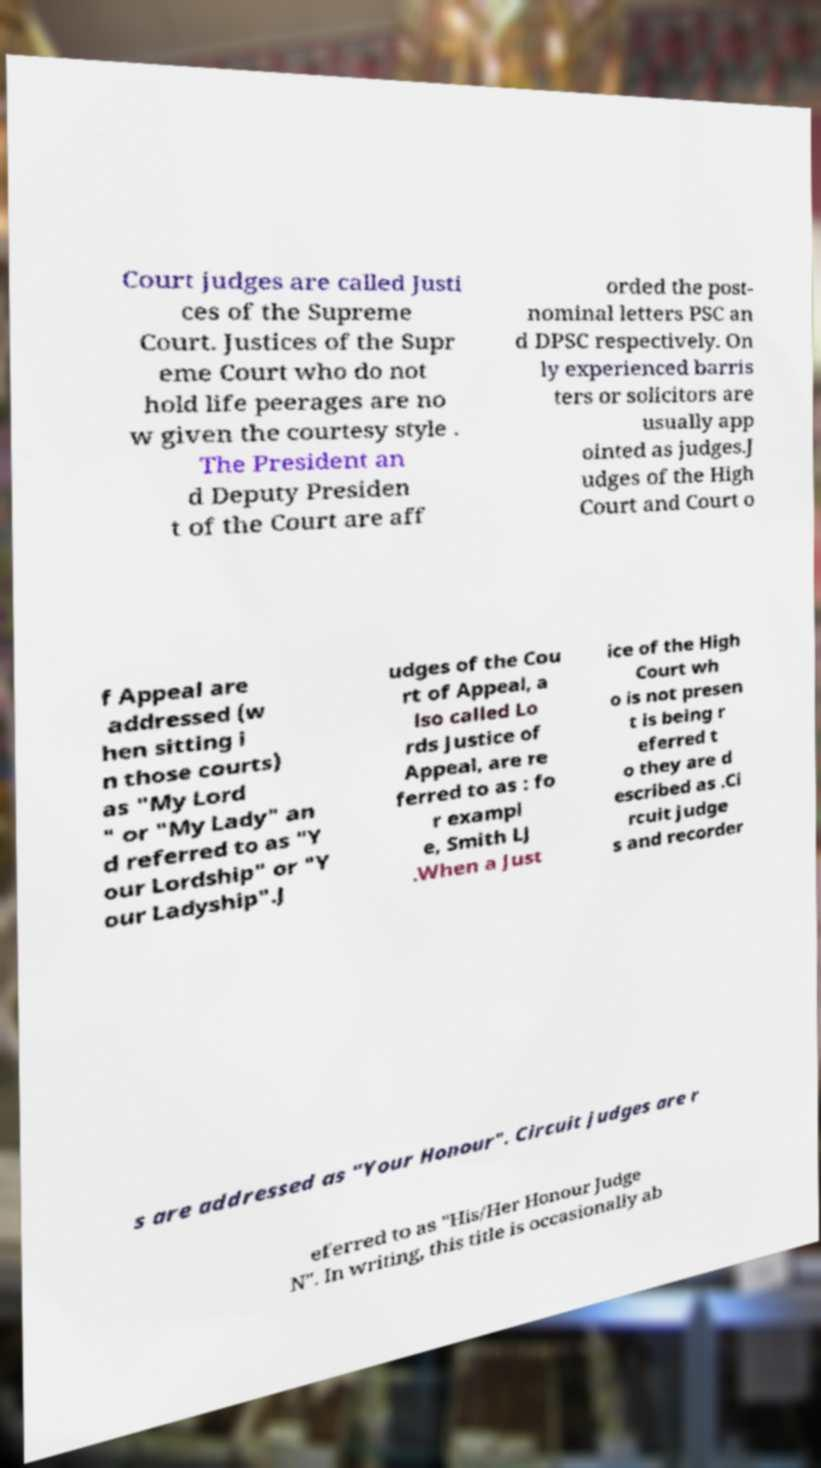Please identify and transcribe the text found in this image. Court judges are called Justi ces of the Supreme Court. Justices of the Supr eme Court who do not hold life peerages are no w given the courtesy style . The President an d Deputy Presiden t of the Court are aff orded the post- nominal letters PSC an d DPSC respectively. On ly experienced barris ters or solicitors are usually app ointed as judges.J udges of the High Court and Court o f Appeal are addressed (w hen sitting i n those courts) as "My Lord " or "My Lady" an d referred to as "Y our Lordship" or "Y our Ladyship".J udges of the Cou rt of Appeal, a lso called Lo rds Justice of Appeal, are re ferred to as : fo r exampl e, Smith LJ .When a Just ice of the High Court wh o is not presen t is being r eferred t o they are d escribed as .Ci rcuit judge s and recorder s are addressed as "Your Honour". Circuit judges are r eferred to as "His/Her Honour Judge N". In writing, this title is occasionally ab 